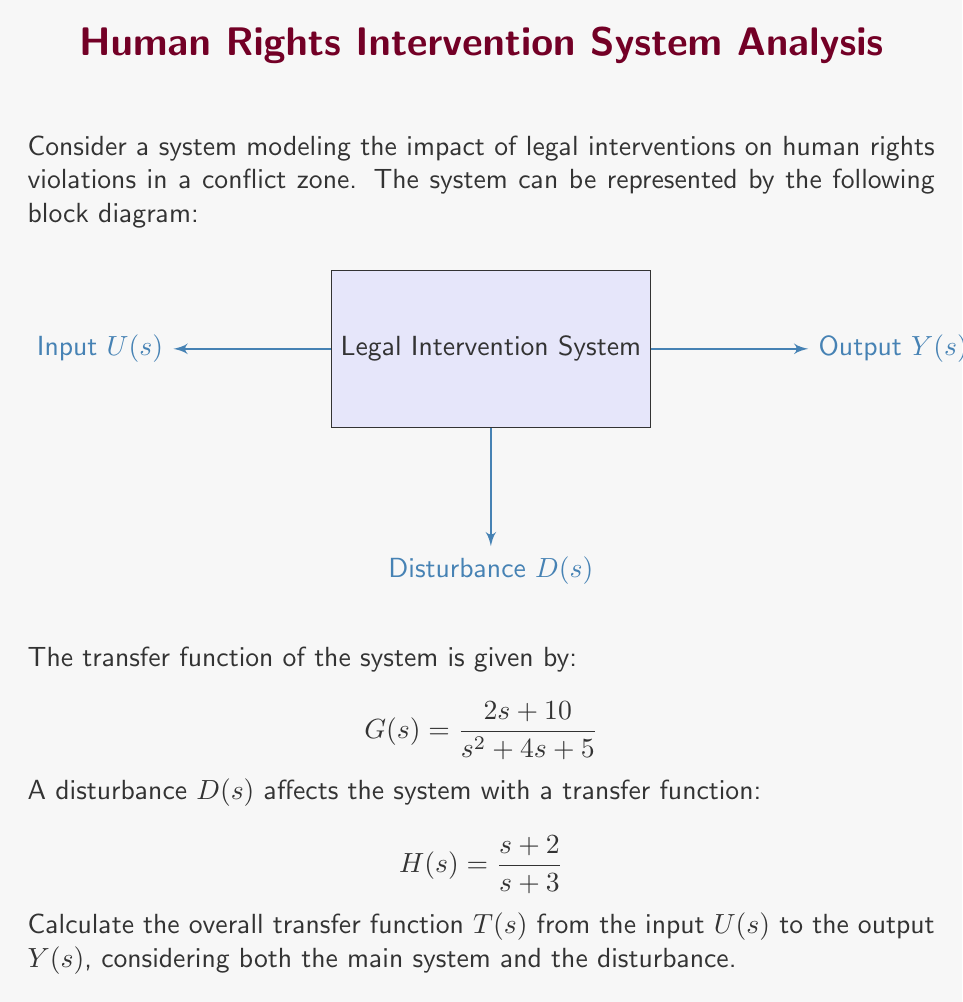Give your solution to this math problem. To solve this problem, we need to follow these steps:

1) The overall transfer function $T(s)$ is the sum of two components:
   a) The transfer function from input $U(s)$ to output $Y(s)$
   b) The transfer function from disturbance $D(s)$ to output $Y(s)$

2) The transfer function from $U(s)$ to $Y(s)$ is simply $G(s)$:

   $$ T_1(s) = G(s) = \frac{2s + 10}{s^2 + 4s + 5} $$

3) The transfer function from $D(s)$ to $Y(s)$ is $H(s)$:

   $$ T_2(s) = H(s) = \frac{s + 2}{s + 3} $$

4) The overall transfer function $T(s)$ is the sum of these two:

   $$ T(s) = T_1(s) + T_2(s) = \frac{2s + 10}{s^2 + 4s + 5} + \frac{s + 2}{s + 3} $$

5) To add these fractions, we need a common denominator. Let's multiply both fractions by $(s + 3)(s^2 + 4s + 5)$:

   $$ T(s) = \frac{(2s + 10)(s + 3)}{(s^2 + 4s + 5)(s + 3)} + \frac{(s + 2)(s^2 + 4s + 5)}{(s + 3)(s^2 + 4s + 5)} $$

6) Expanding the numerators:

   $$ T(s) = \frac{2s^2 + 16s + 30}{(s^2 + 4s + 5)(s + 3)} + \frac{s^3 + 6s^2 + 9s + 10}{(s^2 + 4s + 5)(s + 3)} $$

7) Adding the numerators:

   $$ T(s) = \frac{s^3 + 8s^2 + 25s + 40}{(s^2 + 4s + 5)(s + 3)} $$

This is the overall transfer function of the system, considering both the main system and the disturbance.
Answer: $T(s) = \frac{s^3 + 8s^2 + 25s + 40}{(s^2 + 4s + 5)(s + 3)}$ 